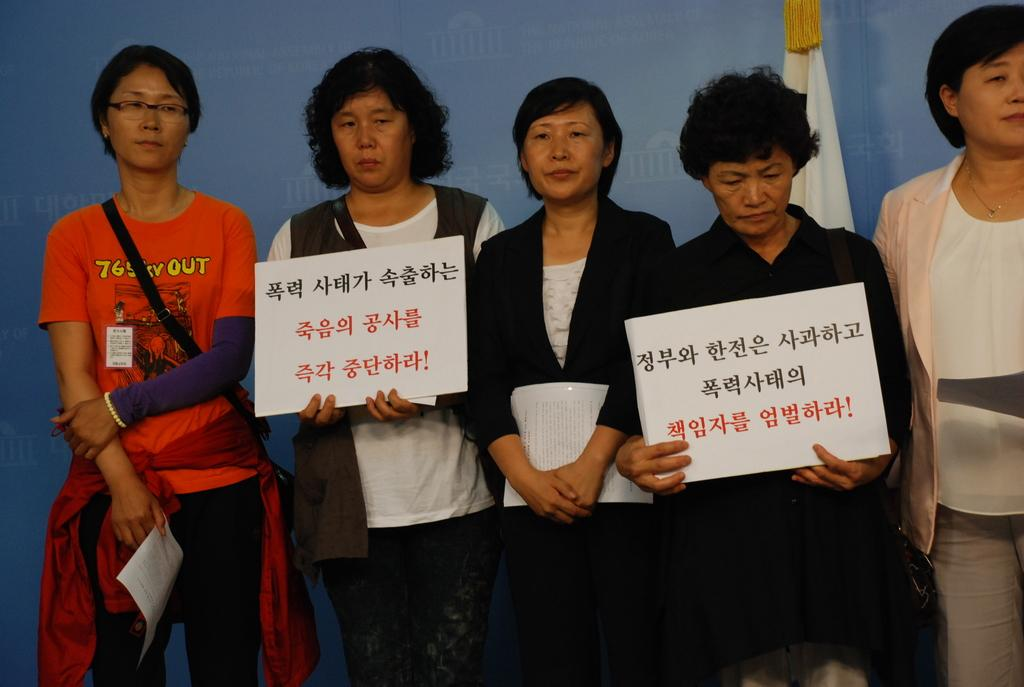What is the main subject of the image? The main subject of the image is a group of people. What are the people in the image doing? The people are standing. What objects are the people holding in their hands? The people are holding placards in their hands. What type of teeth can be seen in the image? There are no teeth present in the image. Is there a river visible in the background of the image? There is no river visible in the image. 